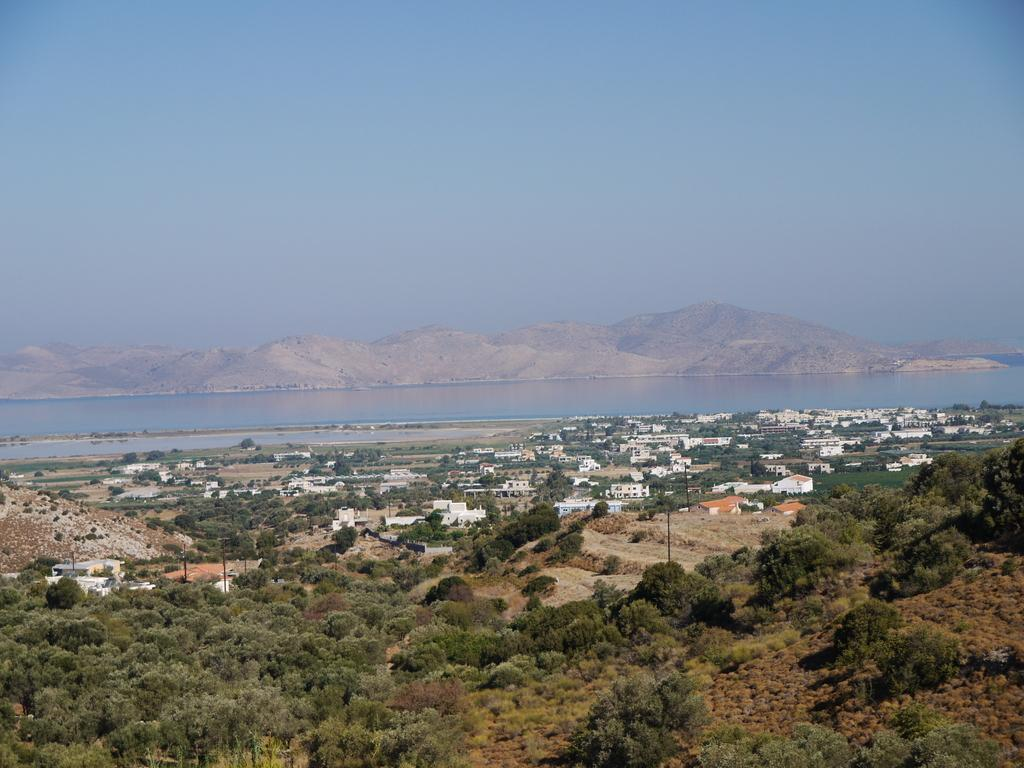What type of natural elements can be seen in the image? There are trees and water visible in the image. What type of man-made structures are present in the image? There are houses in the image. What type of terrain is visible in the image? There are hills in the image. What part of the natural environment is visible in the image? The sky is visible in the image. What type of lipstick is being used in the image? There is no lipstick or any indication of a person applying makeup in the image. 